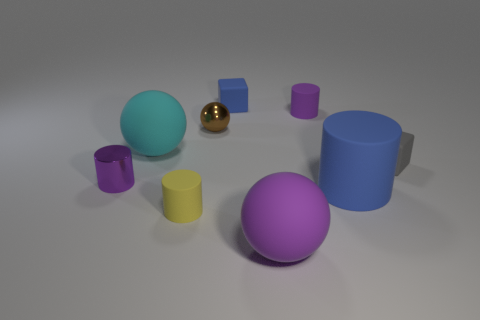Subtract 3 cylinders. How many cylinders are left? 1 Subtract all cubes. How many objects are left? 7 Add 2 shiny objects. How many shiny objects exist? 4 Add 1 big yellow balls. How many objects exist? 10 Subtract all gray cubes. How many cubes are left? 1 Subtract all yellow cylinders. How many cylinders are left? 3 Subtract 0 cyan cylinders. How many objects are left? 9 Subtract all purple cubes. Subtract all brown balls. How many cubes are left? 2 Subtract all brown blocks. How many cyan balls are left? 1 Subtract all cyan objects. Subtract all cyan things. How many objects are left? 7 